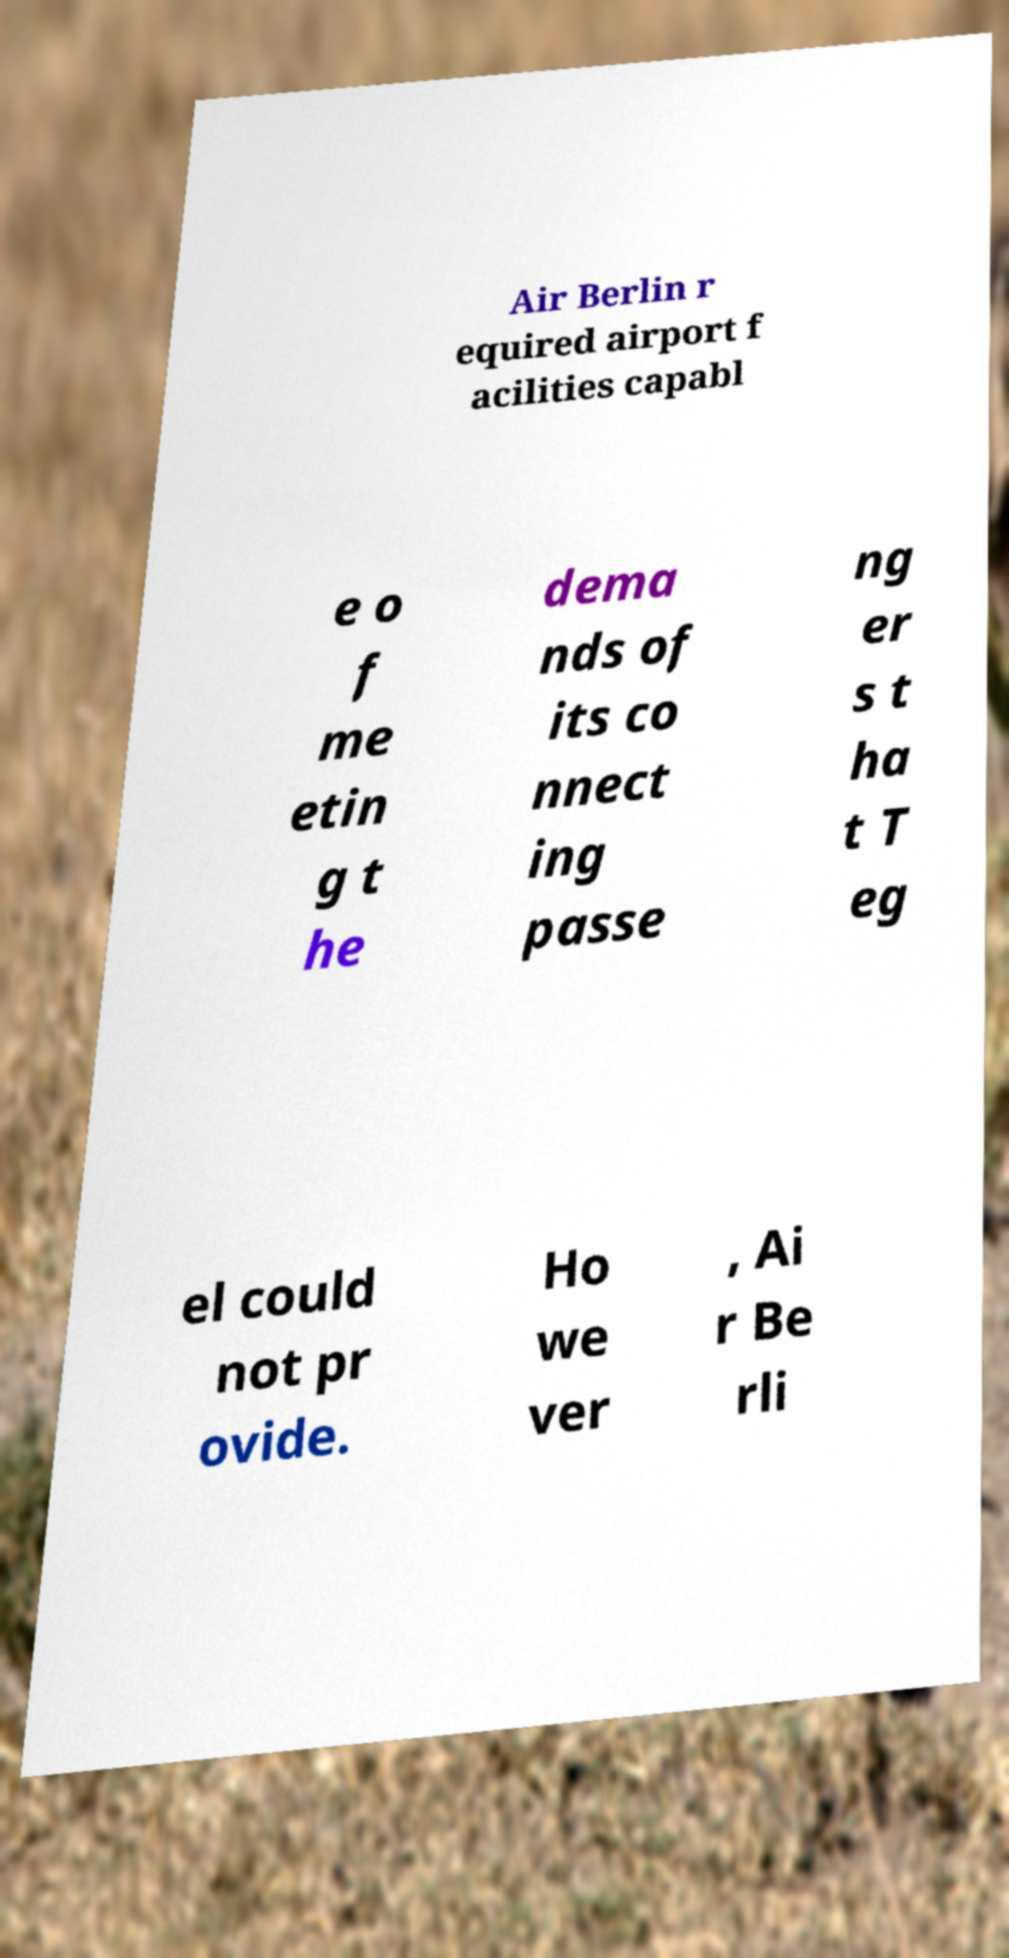Please identify and transcribe the text found in this image. Air Berlin r equired airport f acilities capabl e o f me etin g t he dema nds of its co nnect ing passe ng er s t ha t T eg el could not pr ovide. Ho we ver , Ai r Be rli 